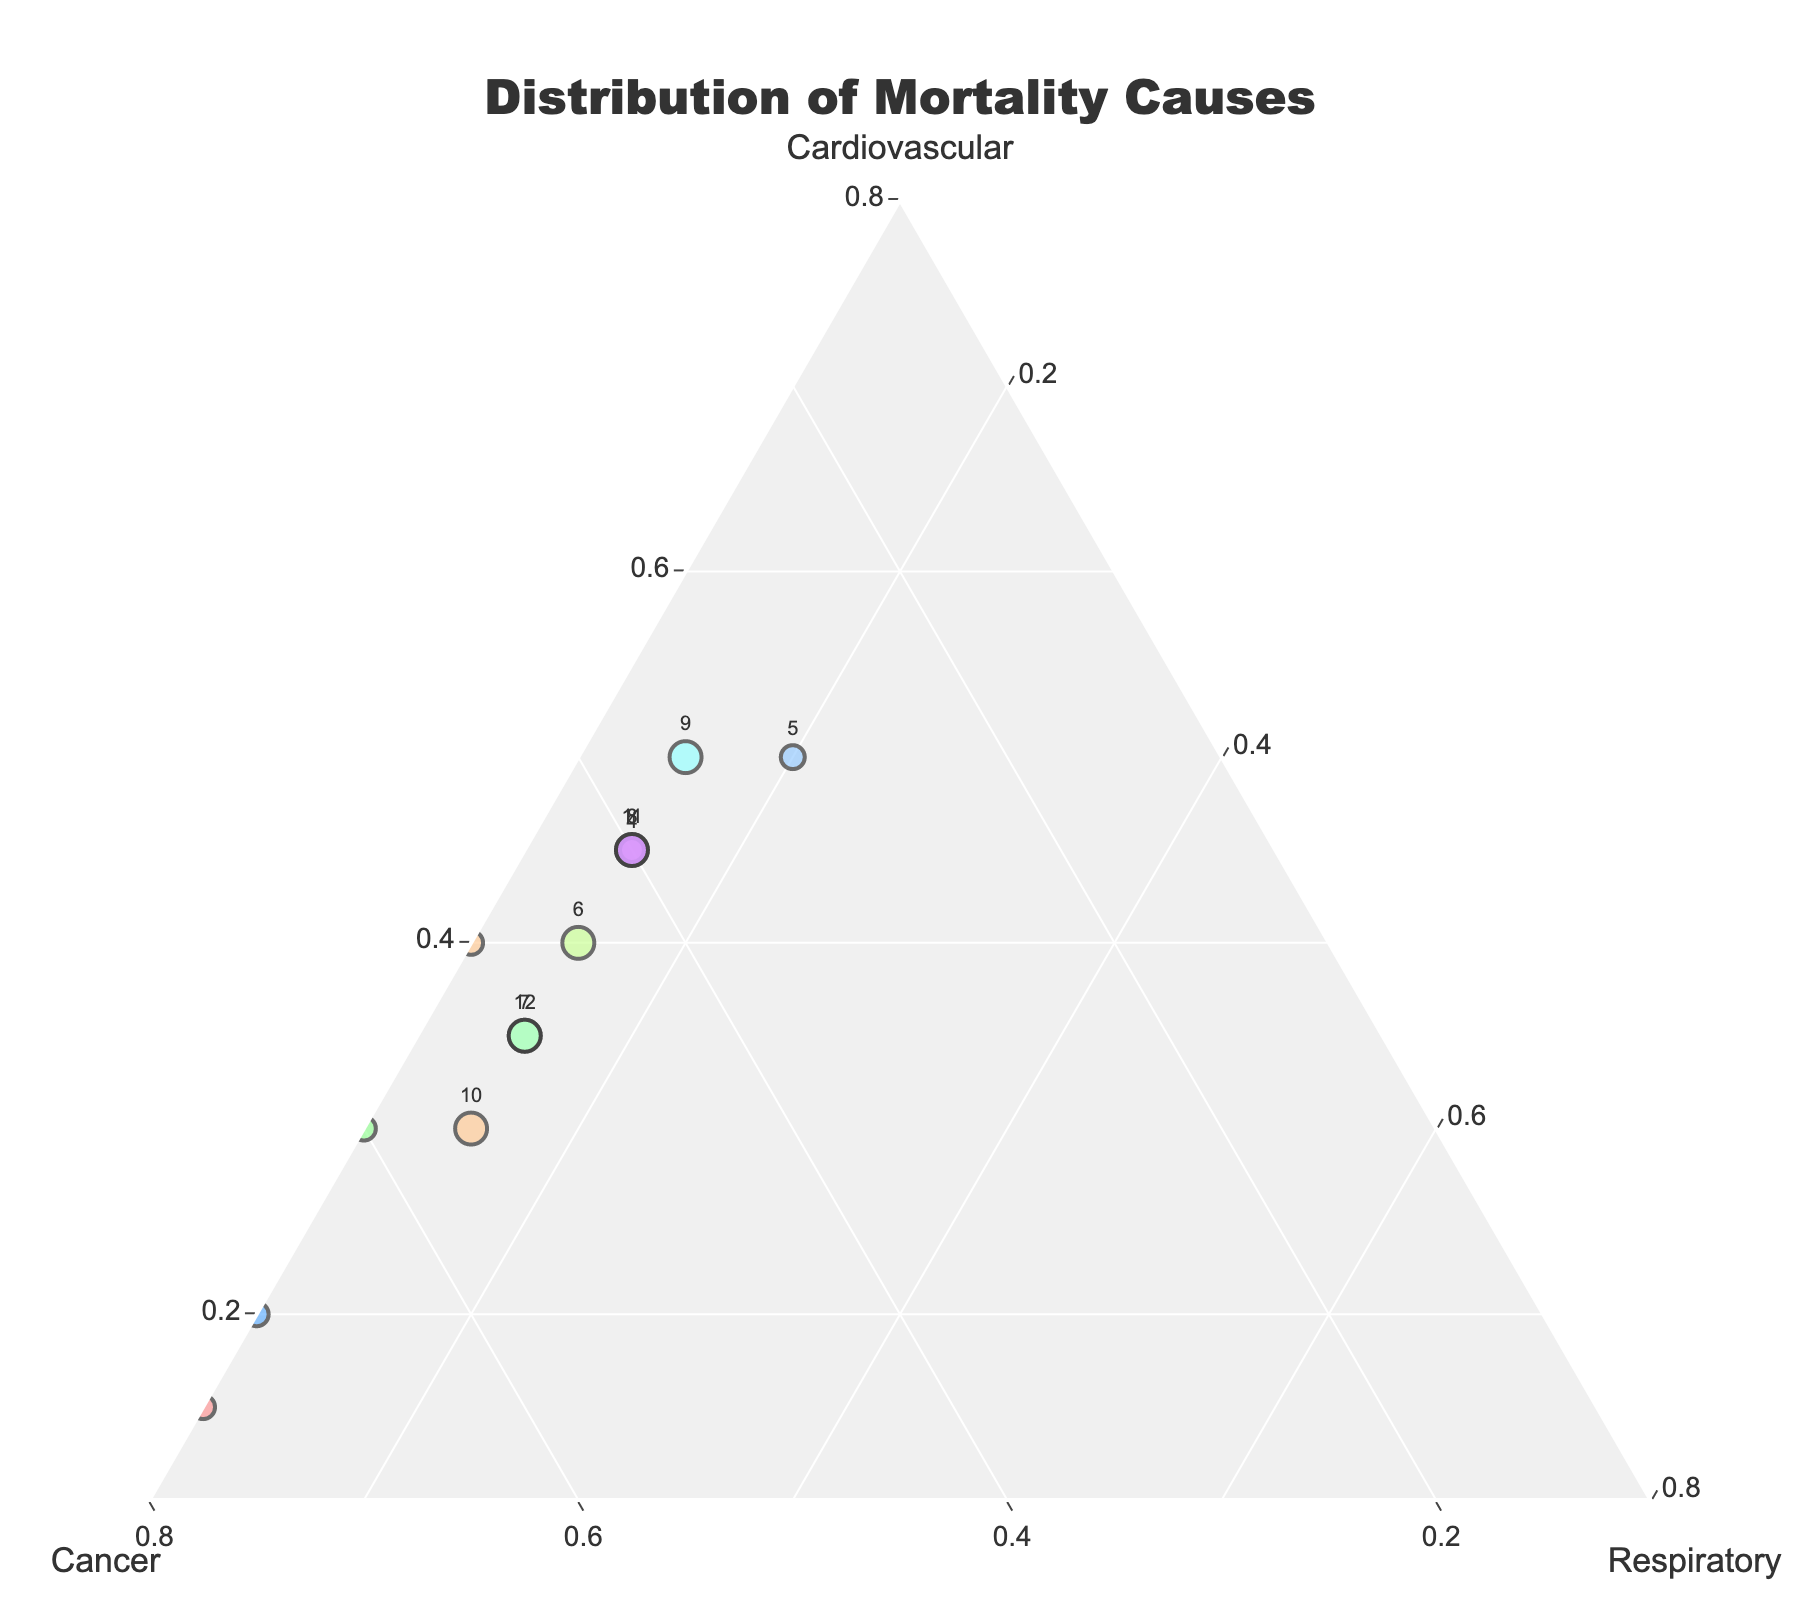What is the title of the figure? The title is usually found at the top of the figure. In this case, the title reads "Distribution of Mortality Causes".
Answer: Distribution of Mortality Causes Which age group has the highest proportion of deaths caused by cancer? From the figure, look for the data point with the highest value on the Cancer axis, which corresponds to the second vertex of the ternary plot. This is the age group 0-14.
Answer: 0-14 How do the distributions of mortality causes compare between urban and rural areas? The urban area data point has a cancer proportion higher than cardiovascular and respiratory while rural areas have a higher proportion of cardiovascular causes than cancer. This should be identified by comparing the two corresponding labeled points in the ternary plot.
Answer: Urban: Higher Cancer; Rural: Higher Cardiovascular Which demographic category (Male or Female) shows a higher proportion of deaths due to cardiovascular diseases? By examining the position of the 'Male' and 'Female' points on the ternary plot, it is seen that 'Male' data is closer to the Cardiovascular apex than 'Female'.
Answer: Male What is the difference in the proportion of deaths caused by respiratory diseases between the age group 60-74 and 75+? Calculate the difference by looking at the respiratory proportion for each age group on the plot: 75+has 0.20 and 60-74 has 0.15, so the difference is 0.20 - 0.15 = 0.05.
Answer: 0.05 For which income group is the proportion of cancer-caused deaths highest? The high-income group shows the highest proportion of cancer deaths, as indicated by its relative position closer to the cancer vertex than the low-income group.
Answer: High Income What is the combined proportion of mortality causes for cardiovascular and respiratory diseases in high-income areas? Add the proportions of cardiovascular and respiratory causes in high-income areas: 0.30 (cardiovascular) + 0.15 (respiratory) = 0.45.
Answer: 0.45 Which age group has the most balanced distribution among all three mortality causes? The group closest to the center of the ternary plot has the most balanced distribution. This is the 60-74 age group with triangular coordinates contribution of 0.45, 0.40, and 0.15.
Answer: 60-74 What is the total proportion of cardiovascular causes for the national average compared to males? The National Average for cardiovascular is 0.40, while for males, it is 0.45. Subtract the national average value from the male value: 0.45 - 0.40 = 0.05.
Answer: 0.05 